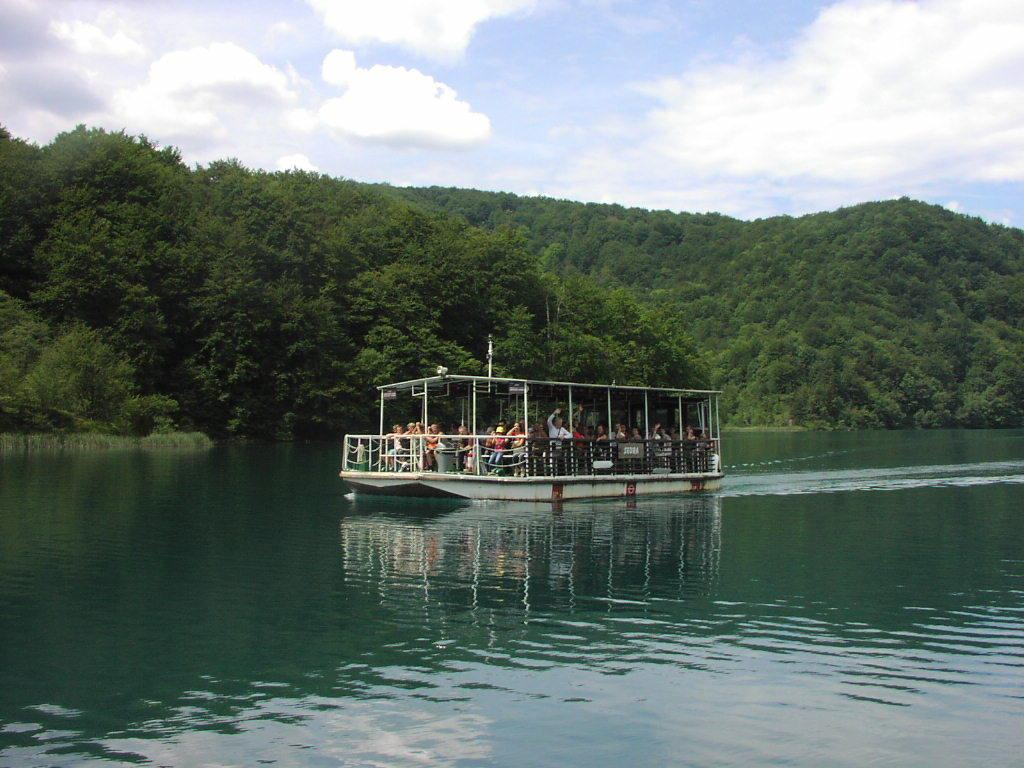What is the main subject of the image? The main subject of the image is a ship. Where is the ship located? The ship is on the water. Are there any people on the ship? Yes, there are people on the ship. What can be seen in the background of the image? Trees and the sky are visible in the image. What is the condition of the sky in the image? The sky is visible with clouds present. What type of whip is being used by the captain of the ship in the image? There is no whip present in the image, and the captain's actions are not depicted. What is the horsepower of the ship's engine in the image? The image does not provide information about the ship's engine or its horsepower. 